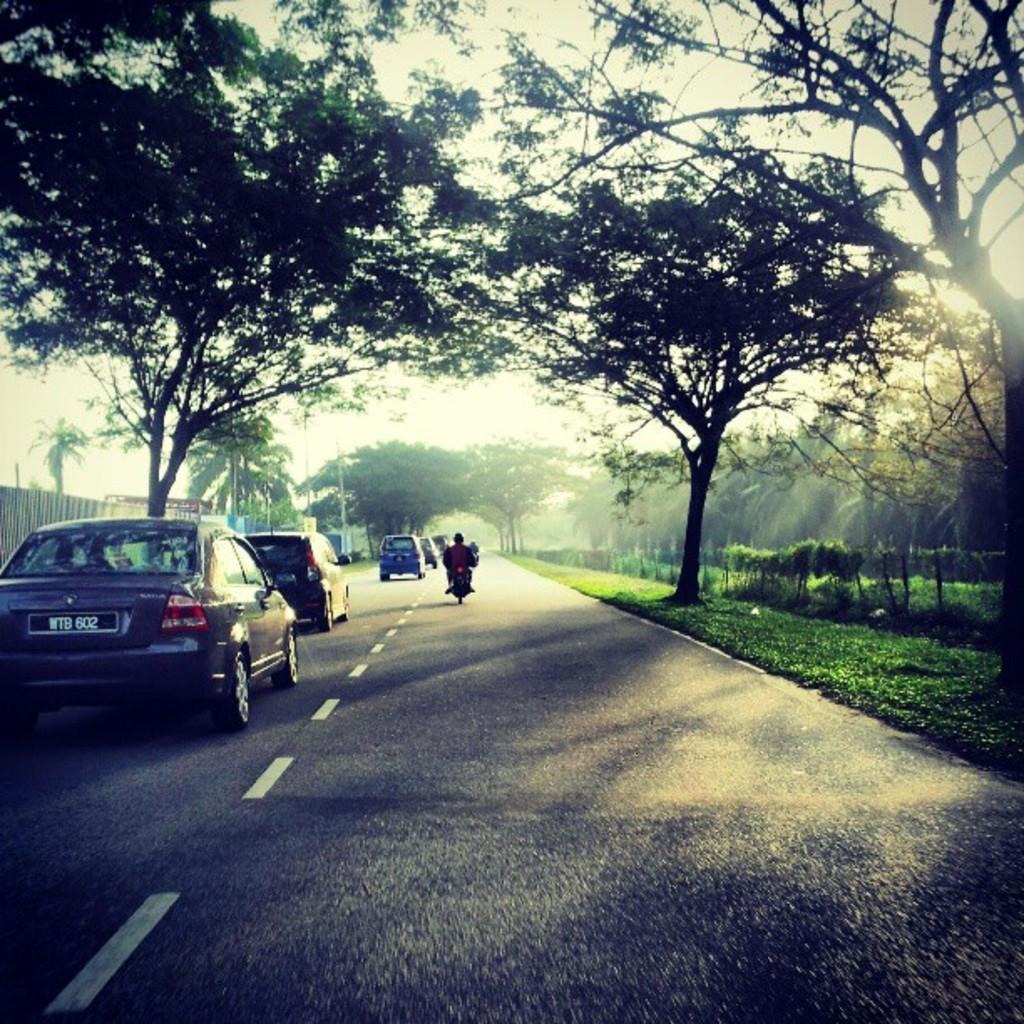What can be seen on the road in the image? There are vehicles on the road in the image. What type of vegetation is present alongside the road? There are trees on either side of the road in the image. What is visible above the road in the image? The sky is visible above the road in the image. How many women are sitting on the trees in the image? There are no women present in the image; it features vehicles on the road and trees alongside it. What type of birds can be seen flying in the sky in the image? There are no birds visible in the image; it only shows vehicles on the road, trees alongside the road, and the sky above. 